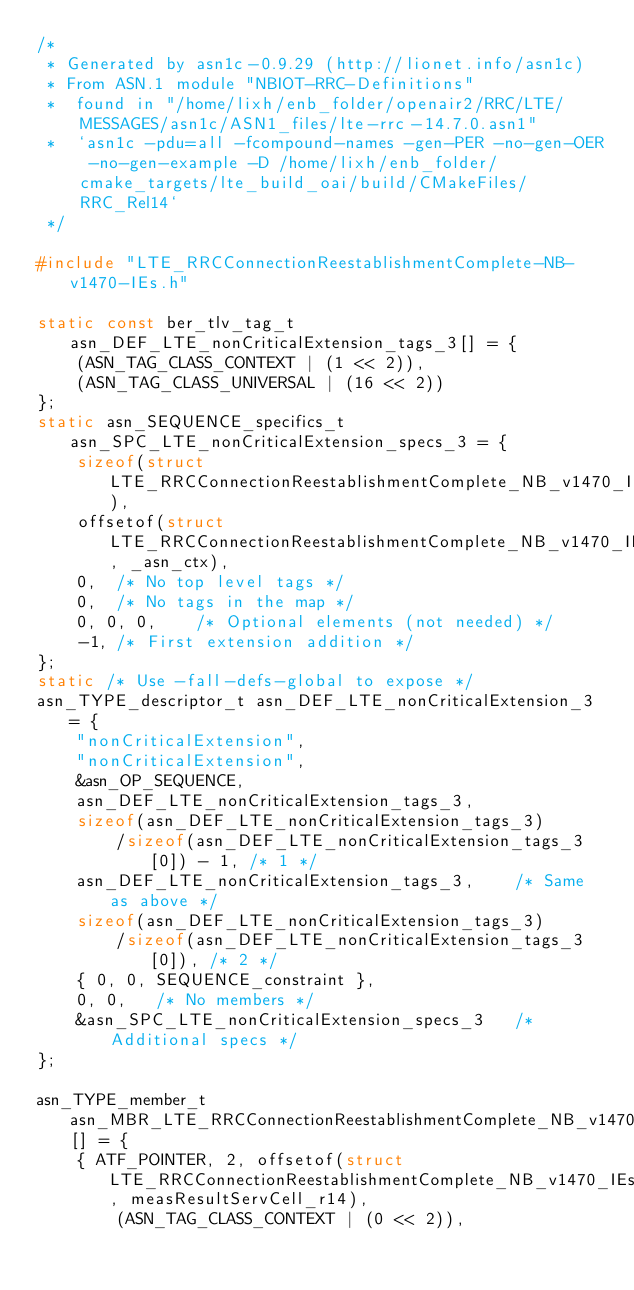Convert code to text. <code><loc_0><loc_0><loc_500><loc_500><_C_>/*
 * Generated by asn1c-0.9.29 (http://lionet.info/asn1c)
 * From ASN.1 module "NBIOT-RRC-Definitions"
 * 	found in "/home/lixh/enb_folder/openair2/RRC/LTE/MESSAGES/asn1c/ASN1_files/lte-rrc-14.7.0.asn1"
 * 	`asn1c -pdu=all -fcompound-names -gen-PER -no-gen-OER -no-gen-example -D /home/lixh/enb_folder/cmake_targets/lte_build_oai/build/CMakeFiles/RRC_Rel14`
 */

#include "LTE_RRCConnectionReestablishmentComplete-NB-v1470-IEs.h"

static const ber_tlv_tag_t asn_DEF_LTE_nonCriticalExtension_tags_3[] = {
	(ASN_TAG_CLASS_CONTEXT | (1 << 2)),
	(ASN_TAG_CLASS_UNIVERSAL | (16 << 2))
};
static asn_SEQUENCE_specifics_t asn_SPC_LTE_nonCriticalExtension_specs_3 = {
	sizeof(struct LTE_RRCConnectionReestablishmentComplete_NB_v1470_IEs__nonCriticalExtension),
	offsetof(struct LTE_RRCConnectionReestablishmentComplete_NB_v1470_IEs__nonCriticalExtension, _asn_ctx),
	0,	/* No top level tags */
	0,	/* No tags in the map */
	0, 0, 0,	/* Optional elements (not needed) */
	-1,	/* First extension addition */
};
static /* Use -fall-defs-global to expose */
asn_TYPE_descriptor_t asn_DEF_LTE_nonCriticalExtension_3 = {
	"nonCriticalExtension",
	"nonCriticalExtension",
	&asn_OP_SEQUENCE,
	asn_DEF_LTE_nonCriticalExtension_tags_3,
	sizeof(asn_DEF_LTE_nonCriticalExtension_tags_3)
		/sizeof(asn_DEF_LTE_nonCriticalExtension_tags_3[0]) - 1, /* 1 */
	asn_DEF_LTE_nonCriticalExtension_tags_3,	/* Same as above */
	sizeof(asn_DEF_LTE_nonCriticalExtension_tags_3)
		/sizeof(asn_DEF_LTE_nonCriticalExtension_tags_3[0]), /* 2 */
	{ 0, 0, SEQUENCE_constraint },
	0, 0,	/* No members */
	&asn_SPC_LTE_nonCriticalExtension_specs_3	/* Additional specs */
};

asn_TYPE_member_t asn_MBR_LTE_RRCConnectionReestablishmentComplete_NB_v1470_IEs_1[] = {
	{ ATF_POINTER, 2, offsetof(struct LTE_RRCConnectionReestablishmentComplete_NB_v1470_IEs, measResultServCell_r14),
		(ASN_TAG_CLASS_CONTEXT | (0 << 2)),</code> 